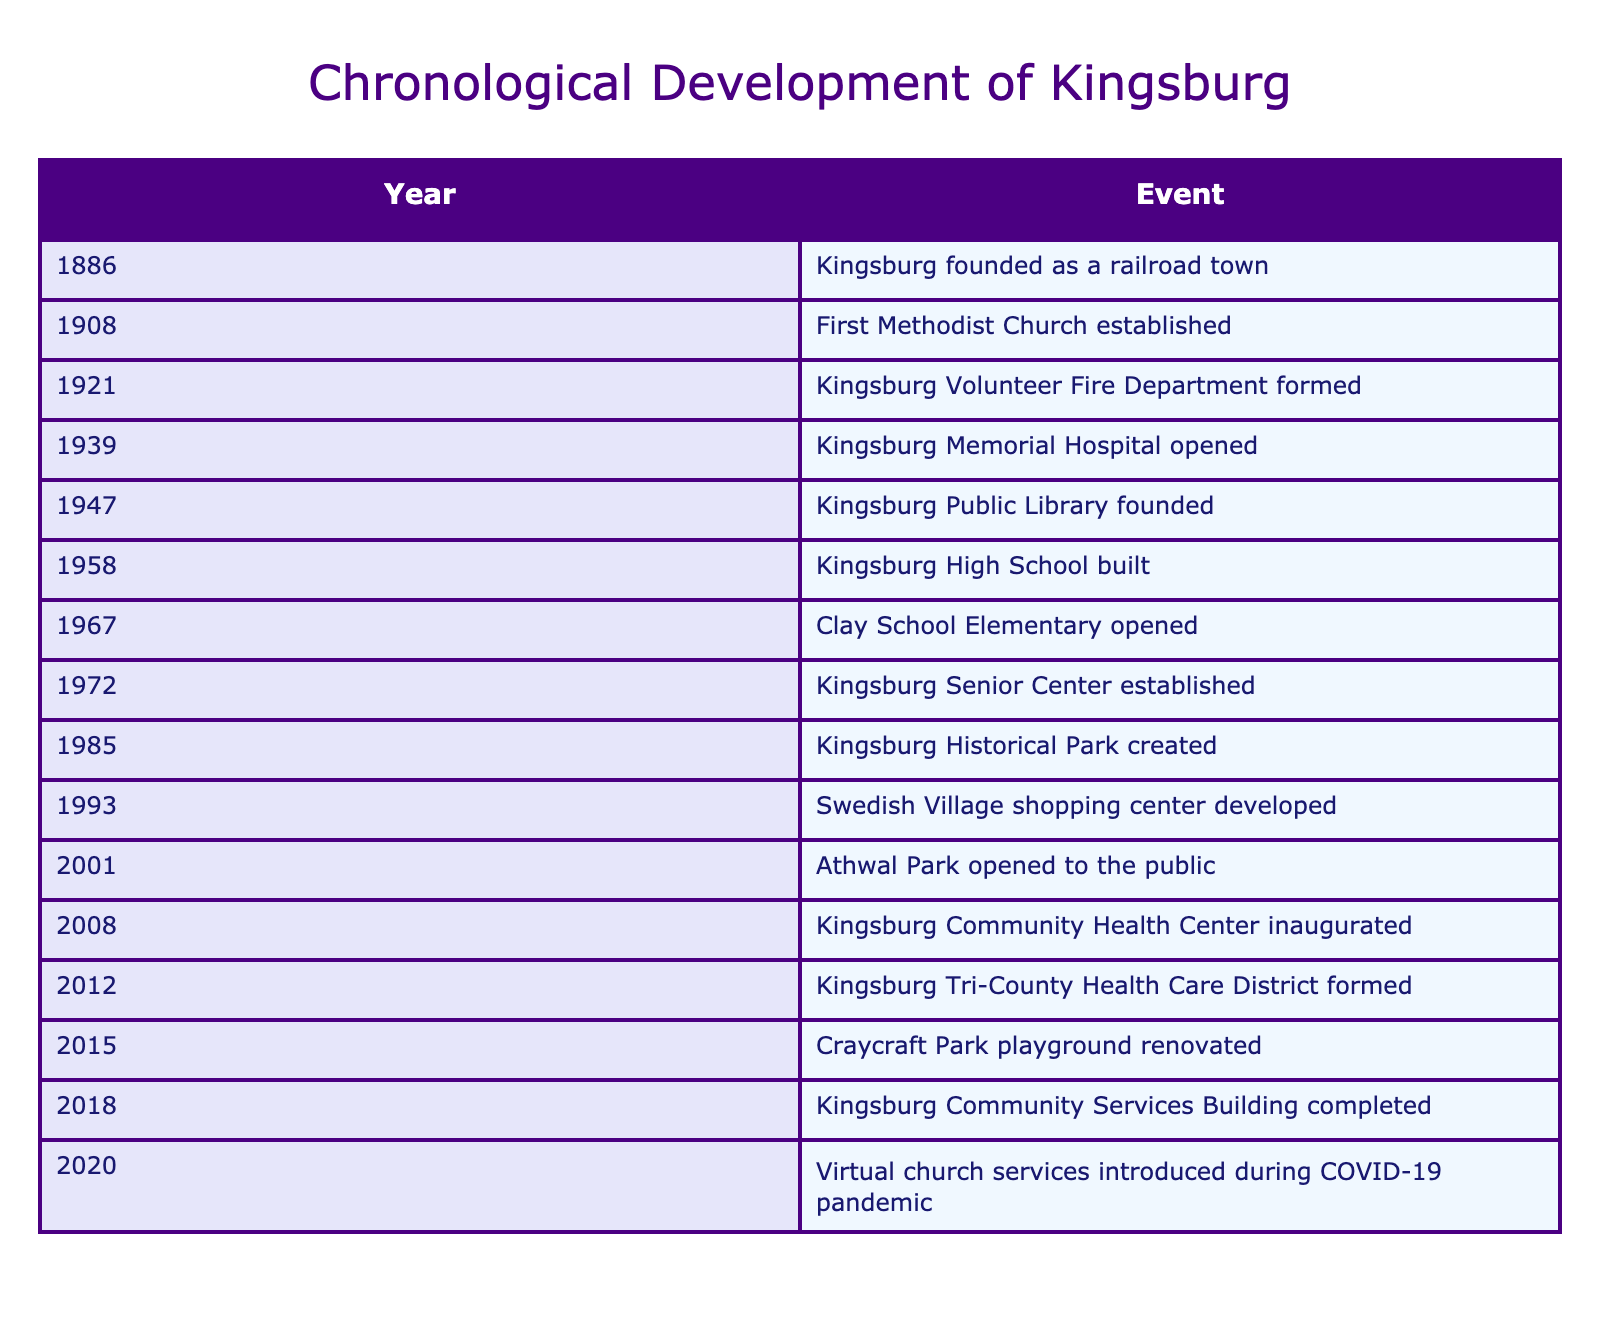What year was Kingsburg founded? The year Kingsburg was founded is listed in the first row of the table, where it states 1886 as the founding year.
Answer: 1886 What significant event occurred in 1921? The table indicates that in 1921, the Kingsburg Volunteer Fire Department was formed, which is a notable community service that began that year.
Answer: Kingsburg Volunteer Fire Department formed How many years passed between the establishment of the First Methodist Church and the opening of Kingsburg Memorial Hospital? The First Methodist Church was established in 1908 and the Kingsburg Memorial Hospital opened in 1939. The difference between these years is 1939 - 1908 = 31 years.
Answer: 31 Did Kingsburg have a public library before the Senior Center was established? The Kingsburg Public Library was founded in 1947 and the Kingsburg Senior Center was established in 1972. Since 1947 occurs before 1972, the answer is yes.
Answer: Yes What are the years when both the high school and elementary school were built? According to the table, Kingsburg High School was built in 1958 and Clay School Elementary opened in 1967. Thus, the years mentioned are 1958 for the high school and 1967 for the elementary school.
Answer: 1958, 1967 What was the average year for the establishment of the services and facilities listed? To find the average year, we add all the years: 1886 + 1908 + 1921 + 1939 + 1947 + 1958 + 1967 + 1972 + 1985 + 1993 + 2001 + 2008 + 2012 + 2015 + 2018 + 2020 =  22716. There are 16 events, so the average year is 22716 / 16 = 1419.75. Given that we have years only, we will consider this to be around 2005 when approximating to a whole number.
Answer: 2005 Which event occurred last among the listed developments? By looking at the last row of the table, the event that occurred last is the introduction of virtual church services during the COVID-19 pandemic in 2020.
Answer: Virtual church services introduced during COVID-19 pandemic How long after the opening of Athwal Park did the Kingsburg Community Health Center inaugurate? Athwal Park opened in 2001 and the Kingsburg Community Health Center was inaugurated in 2008. The time difference is 2008 - 2001 = 7 years.
Answer: 7 years 